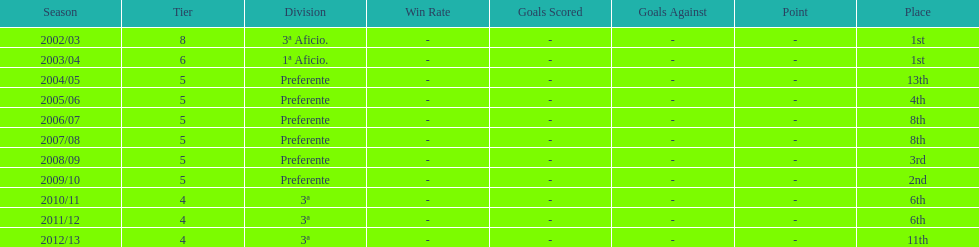How many times did internacional de madrid cf end the season at the top of their division? 2. 